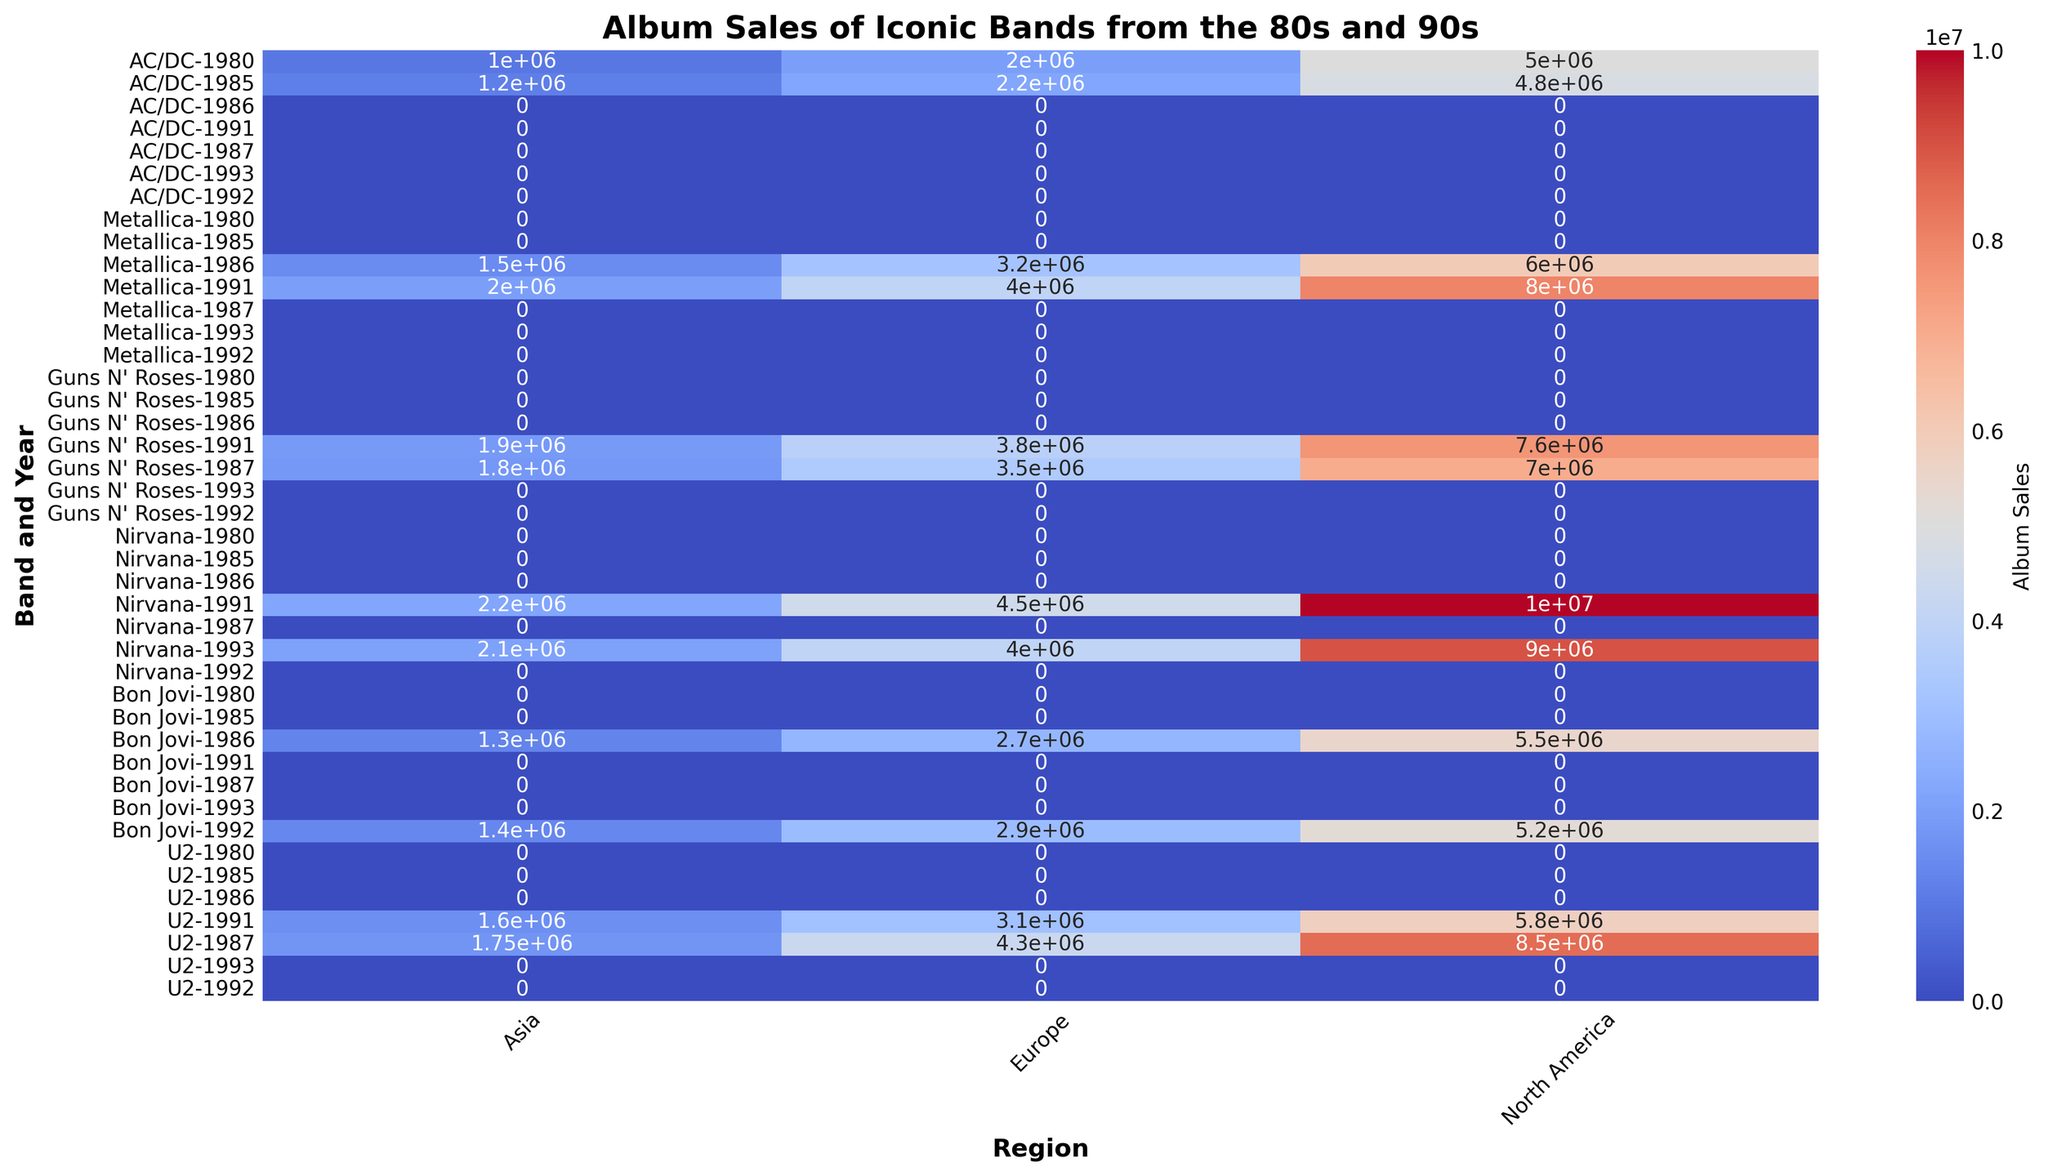What is the sum of album sales for AC/DC in North America across all years? First, find the sales for AC/DC in North America for each year (1980: 5,000,000 and 1985: 4,800,000). Then, sum these values: 5,000,000 + 4,800,000 = 9,800,000.
Answer: 9,800,000 Which band had the highest album sales in Asia in 1991? Compare the album sales in Asia for all bands in the year 1991. Metallica sold 2,000,000, Guns N' Roses sold 1,900,000, Nirvana sold 2,200,000, U2 sold 1,600,000. Nirvana has the highest sales with 2,200,000.
Answer: Nirvana Between 1987 and 1991, which band showed the largest increase in sales in Europe? Calculate the difference in sales between 1991 and 1987 for each band in Europe: Guns N' Roses (3,800,000 - 3,500,000 = 300,000), Nirvana (4,500,000 - N/A, since no data for 1987), U2 (3,100,000 - 4,300,000 = -1,200,000). Nirvana has no valid data for comparison and U2 shows a decrease, so Guns N' Roses shows the largest increase of 300,000.
Answer: Guns N' Roses Which region has the darkest color for album sales in 1986? By examining the heatmap, the region with the darkest color (indicating the highest sales) for 1986 should be identified. In 1986, North America shows the highest sale for Metallica with 6,000,000, which is the darkest color.
Answer: North America Did any band have identical album sales in two different regions in the same year? Checking all the data points for identical values within the same year, Metallica's sales in 1991 in Asia and Europe are 2,000,000 and 4,000,000, respectively. Similarly, others have different values across regions. Therefore, no identical sales in two regions in the same year.
Answer: No What is the total album sales for Nirvana in 1991 across all regions? Sum the sales for Nirvana in 1991 across North America, Europe, and Asia (10,000,000 + 4,500,000 + 2,200,000): 10,000,000 + 4,500,000 + 2,200,000 = 16,700,000.
Answer: 16,700,000 What is the difference in album sales between Guns N' Roses and U2 in North America in 1987? Subtract U2's North American sales in 1987 from Guns N' Roses' sales: 7,000,000 (Guns N' Roses) - 8,500,000 (U2) = -1,500,000.
Answer: -1,500,000 Which band has the highest sales in Europe for any given year, and what is the figure? Examine the heatmap to find the highest single sales figure in Europe. Nirvana in 1991 has the highest sales with 4,500,000.
Answer: Nirvana, 4,500,000 How does the color intensity compare between AC/DC's 1980 and 1985 sales in North America? Comparing the color intensities, 1980 has a darker shade compared to 1985, indicating that sales were slightly higher in 1980 (5,000,000) than in 1985 (4,800,000).
Answer: Darker in 1980 What is the average album sales for Bon Jovi in Asia across the given years? Calculate the average of Bon Jovi’s sales in Asia across 1986 and 1992: (1,300,000 + 1,400,000)/2 = 2,700,000/2 = 1,350,000.
Answer: 1,350,000 